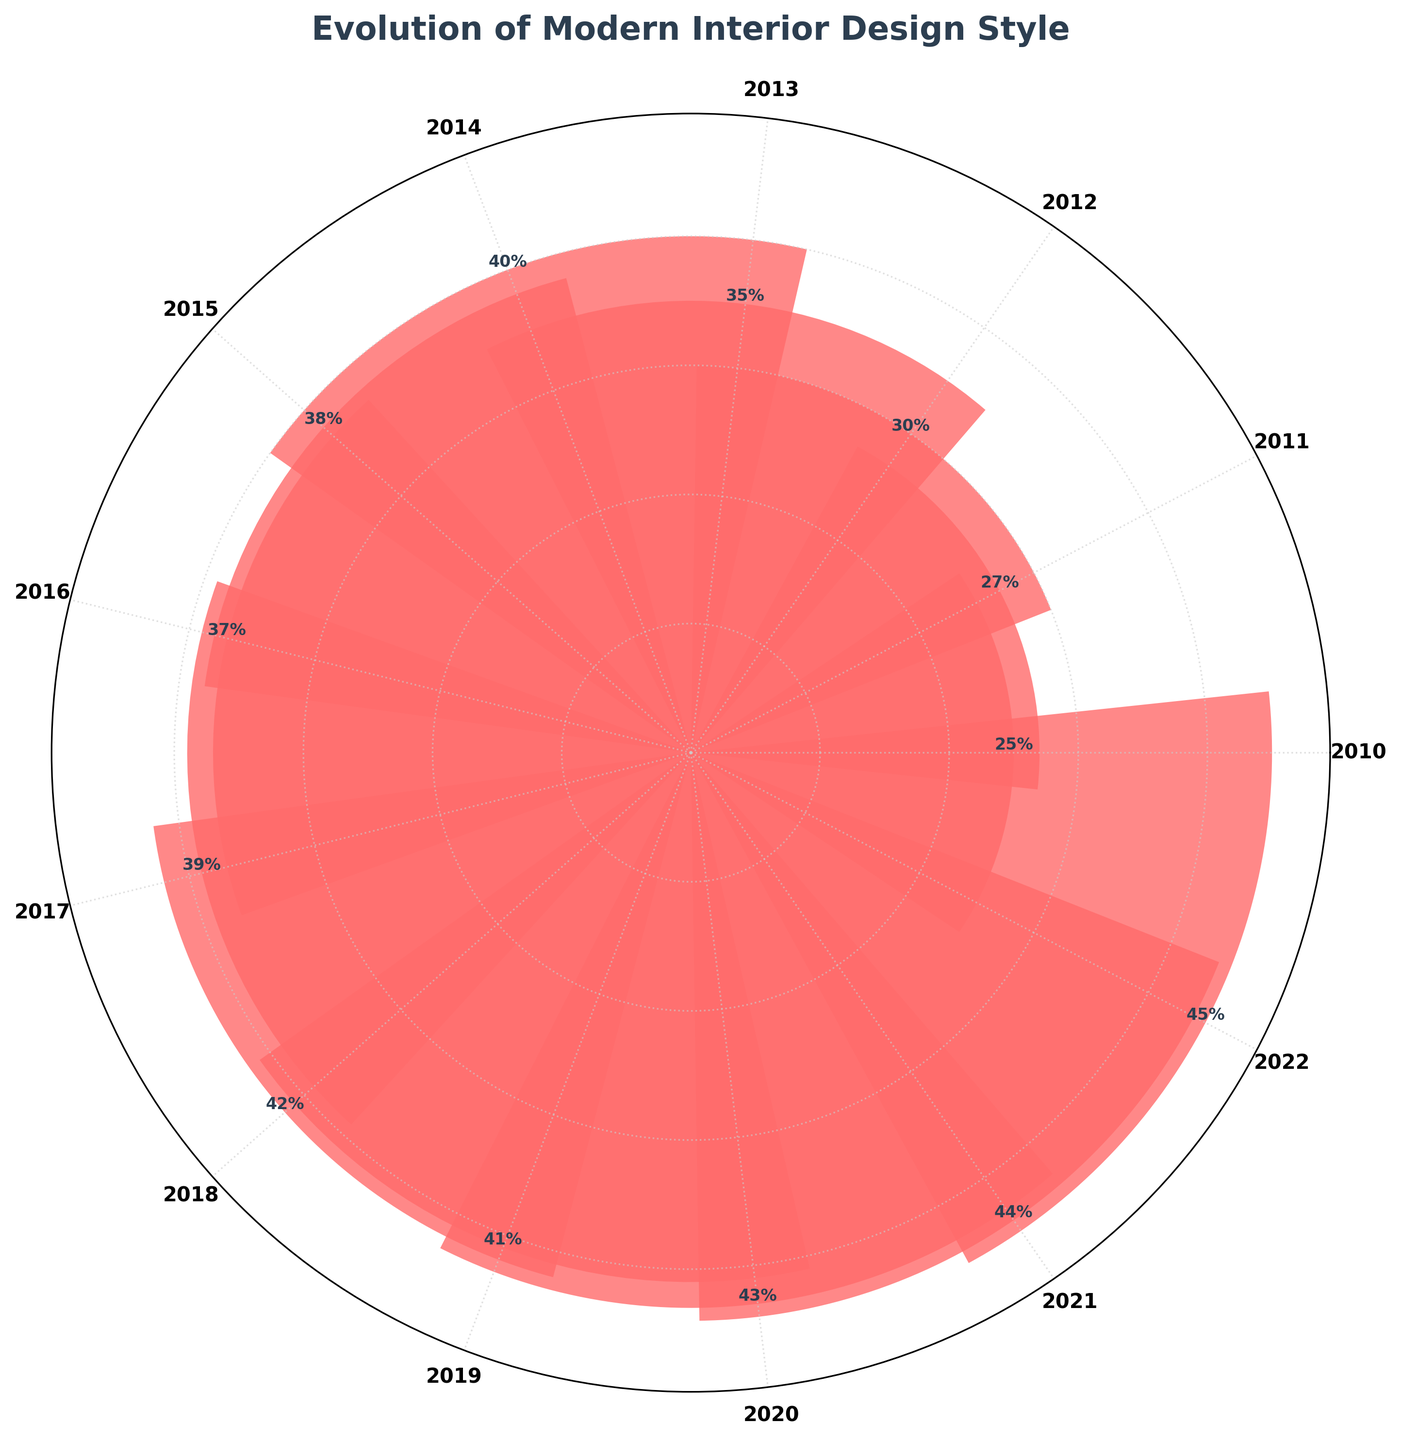What is the title of the chart? The title of the chart is usually displayed at the top and serves to describe the main topic or content of the figure.
Answer: Evolution of Modern Interior Design Style What is the general trend of the Modern design style between 2010 and 2022? By observing the heights of the bars from 2010 to 2022, it's clear that the Modern design style increases consistently over the years. For instance, in 2010 it starts at 25% and reaches 45% by 2022.
Answer: Increasing trend What is the highest recorded percentage of the Modern design style? The tallest bar indicates the highest value. In the figure, the Modern style reaches its peak in 2022 at 45%.
Answer: 45% How does the percentage of Modern style in 2015 compare to the percentage in 2020? Observe the height of the corresponding bars for 2015 and 2020. The percentage in 2015 is 38%, while in 2020 it is 43%. Therefore, the percentage increased by 5% from 2015 to 2020.
Answer: 5% increase In which year did the Modern style have a notable dip, and what was the percentage? By comparing the bars, the notable dip occurred between 2014 and 2015, falling from 40% to 38%.
Answer: 2015, 38% What is the average percentage of Modern design style from 2010 to 2022? To find the average, sum the percentages for all years and divide by the number of years. The total percentage is 493% (25+27+30+35+40+38+37+39+42+41+43+44+45). There are 13 years. Thus, the average is 493/13 ≈ 37.92%.
Answer: 37.92% How many times did the Modern design style experience a decrease in percentage from one year to the next? Count the years where the percentage decreased compared to the previous year. This happened twice, from 2014 to 2015 (40% to 38%) and from 2015 to 2016 (38% to 37%).
Answer: 2 times Is there any year where the Modern design style remained the same as the previous year? By examining the bars for each year, there was no year where the Modern design percentage remained unchanged from the previous year.
Answer: No Which year had the lowest percentage for the Modern design style and what was that percentage? The lowest bar indicates the minimum value. In the figure, 2010 has the lowest percentage at 25%.
Answer: 2010, 25% How does the trend of Modern design style in 2012 compare to its trend in 2021? Compare the bar heights for 2012 (30%) and 2021 (44%). From this, it's apparent that there has been a substantial increase of 14% between these two years.
Answer: 14% increase 